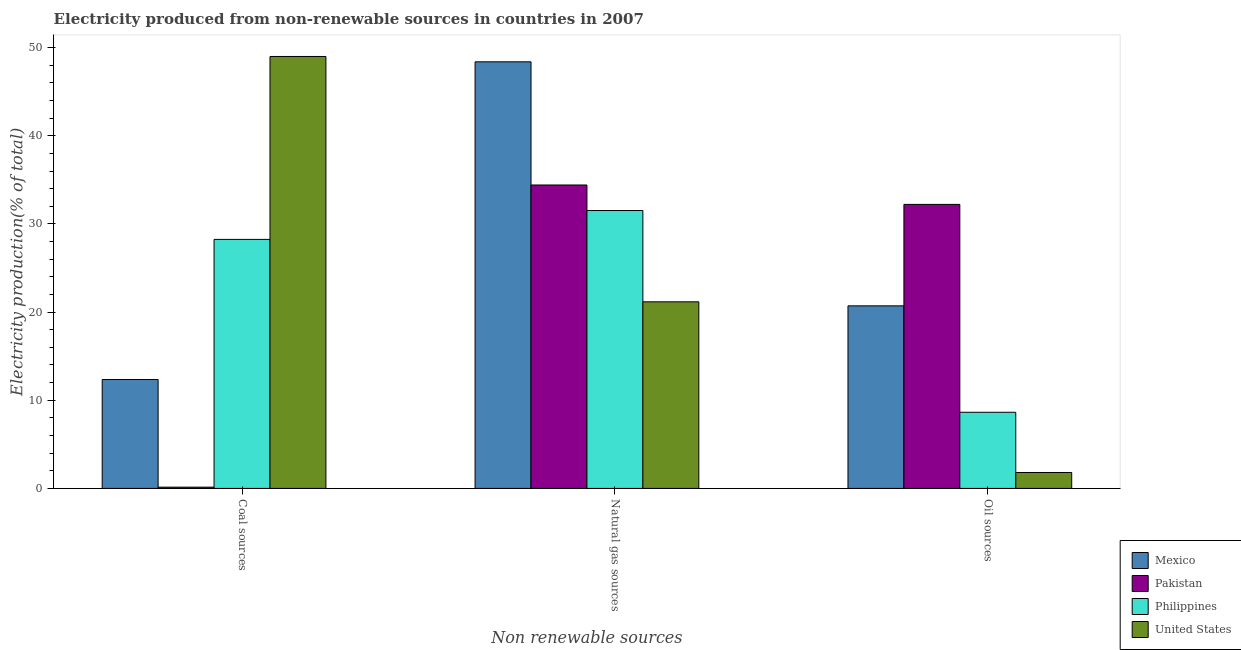Are the number of bars per tick equal to the number of legend labels?
Give a very brief answer. Yes. How many bars are there on the 3rd tick from the left?
Offer a very short reply. 4. How many bars are there on the 3rd tick from the right?
Your response must be concise. 4. What is the label of the 1st group of bars from the left?
Give a very brief answer. Coal sources. What is the percentage of electricity produced by natural gas in United States?
Your answer should be compact. 21.17. Across all countries, what is the maximum percentage of electricity produced by natural gas?
Make the answer very short. 48.39. Across all countries, what is the minimum percentage of electricity produced by coal?
Provide a succinct answer. 0.14. What is the total percentage of electricity produced by oil sources in the graph?
Your answer should be compact. 63.37. What is the difference between the percentage of electricity produced by oil sources in Philippines and that in United States?
Give a very brief answer. 6.83. What is the difference between the percentage of electricity produced by natural gas in Mexico and the percentage of electricity produced by coal in Pakistan?
Your answer should be very brief. 48.24. What is the average percentage of electricity produced by oil sources per country?
Offer a terse response. 15.84. What is the difference between the percentage of electricity produced by oil sources and percentage of electricity produced by natural gas in Pakistan?
Ensure brevity in your answer.  -2.2. In how many countries, is the percentage of electricity produced by coal greater than 44 %?
Your answer should be compact. 1. What is the ratio of the percentage of electricity produced by coal in Mexico to that in Philippines?
Keep it short and to the point. 0.44. What is the difference between the highest and the second highest percentage of electricity produced by oil sources?
Your response must be concise. 11.51. What is the difference between the highest and the lowest percentage of electricity produced by oil sources?
Keep it short and to the point. 30.41. Is it the case that in every country, the sum of the percentage of electricity produced by coal and percentage of electricity produced by natural gas is greater than the percentage of electricity produced by oil sources?
Ensure brevity in your answer.  Yes. Are the values on the major ticks of Y-axis written in scientific E-notation?
Provide a succinct answer. No. Does the graph contain grids?
Offer a terse response. No. Where does the legend appear in the graph?
Ensure brevity in your answer.  Bottom right. How many legend labels are there?
Your response must be concise. 4. How are the legend labels stacked?
Provide a short and direct response. Vertical. What is the title of the graph?
Make the answer very short. Electricity produced from non-renewable sources in countries in 2007. Does "Germany" appear as one of the legend labels in the graph?
Your answer should be compact. No. What is the label or title of the X-axis?
Ensure brevity in your answer.  Non renewable sources. What is the label or title of the Y-axis?
Your answer should be very brief. Electricity production(% of total). What is the Electricity production(% of total) in Mexico in Coal sources?
Your response must be concise. 12.35. What is the Electricity production(% of total) in Pakistan in Coal sources?
Offer a terse response. 0.14. What is the Electricity production(% of total) in Philippines in Coal sources?
Provide a succinct answer. 28.24. What is the Electricity production(% of total) in United States in Coal sources?
Offer a terse response. 48.99. What is the Electricity production(% of total) in Mexico in Natural gas sources?
Ensure brevity in your answer.  48.39. What is the Electricity production(% of total) of Pakistan in Natural gas sources?
Make the answer very short. 34.42. What is the Electricity production(% of total) in Philippines in Natural gas sources?
Offer a very short reply. 31.52. What is the Electricity production(% of total) of United States in Natural gas sources?
Make the answer very short. 21.17. What is the Electricity production(% of total) in Mexico in Oil sources?
Offer a very short reply. 20.71. What is the Electricity production(% of total) of Pakistan in Oil sources?
Ensure brevity in your answer.  32.22. What is the Electricity production(% of total) of Philippines in Oil sources?
Your answer should be compact. 8.64. What is the Electricity production(% of total) of United States in Oil sources?
Give a very brief answer. 1.81. Across all Non renewable sources, what is the maximum Electricity production(% of total) in Mexico?
Offer a very short reply. 48.39. Across all Non renewable sources, what is the maximum Electricity production(% of total) of Pakistan?
Provide a succinct answer. 34.42. Across all Non renewable sources, what is the maximum Electricity production(% of total) in Philippines?
Give a very brief answer. 31.52. Across all Non renewable sources, what is the maximum Electricity production(% of total) in United States?
Offer a terse response. 48.99. Across all Non renewable sources, what is the minimum Electricity production(% of total) in Mexico?
Provide a short and direct response. 12.35. Across all Non renewable sources, what is the minimum Electricity production(% of total) in Pakistan?
Provide a short and direct response. 0.14. Across all Non renewable sources, what is the minimum Electricity production(% of total) in Philippines?
Provide a short and direct response. 8.64. Across all Non renewable sources, what is the minimum Electricity production(% of total) in United States?
Your answer should be very brief. 1.81. What is the total Electricity production(% of total) in Mexico in the graph?
Your answer should be very brief. 81.45. What is the total Electricity production(% of total) of Pakistan in the graph?
Keep it short and to the point. 66.77. What is the total Electricity production(% of total) of Philippines in the graph?
Your answer should be compact. 68.4. What is the total Electricity production(% of total) in United States in the graph?
Ensure brevity in your answer.  71.97. What is the difference between the Electricity production(% of total) in Mexico in Coal sources and that in Natural gas sources?
Offer a terse response. -36.03. What is the difference between the Electricity production(% of total) of Pakistan in Coal sources and that in Natural gas sources?
Make the answer very short. -34.27. What is the difference between the Electricity production(% of total) of Philippines in Coal sources and that in Natural gas sources?
Make the answer very short. -3.27. What is the difference between the Electricity production(% of total) of United States in Coal sources and that in Natural gas sources?
Provide a short and direct response. 27.83. What is the difference between the Electricity production(% of total) of Mexico in Coal sources and that in Oil sources?
Offer a very short reply. -8.35. What is the difference between the Electricity production(% of total) in Pakistan in Coal sources and that in Oil sources?
Offer a terse response. -32.07. What is the difference between the Electricity production(% of total) in Philippines in Coal sources and that in Oil sources?
Your response must be concise. 19.61. What is the difference between the Electricity production(% of total) of United States in Coal sources and that in Oil sources?
Your answer should be compact. 47.19. What is the difference between the Electricity production(% of total) in Mexico in Natural gas sources and that in Oil sources?
Provide a succinct answer. 27.68. What is the difference between the Electricity production(% of total) in Pakistan in Natural gas sources and that in Oil sources?
Give a very brief answer. 2.2. What is the difference between the Electricity production(% of total) in Philippines in Natural gas sources and that in Oil sources?
Ensure brevity in your answer.  22.88. What is the difference between the Electricity production(% of total) of United States in Natural gas sources and that in Oil sources?
Your answer should be compact. 19.36. What is the difference between the Electricity production(% of total) in Mexico in Coal sources and the Electricity production(% of total) in Pakistan in Natural gas sources?
Ensure brevity in your answer.  -22.06. What is the difference between the Electricity production(% of total) in Mexico in Coal sources and the Electricity production(% of total) in Philippines in Natural gas sources?
Make the answer very short. -19.17. What is the difference between the Electricity production(% of total) of Mexico in Coal sources and the Electricity production(% of total) of United States in Natural gas sources?
Offer a terse response. -8.81. What is the difference between the Electricity production(% of total) of Pakistan in Coal sources and the Electricity production(% of total) of Philippines in Natural gas sources?
Provide a succinct answer. -31.38. What is the difference between the Electricity production(% of total) in Pakistan in Coal sources and the Electricity production(% of total) in United States in Natural gas sources?
Provide a short and direct response. -21.02. What is the difference between the Electricity production(% of total) in Philippines in Coal sources and the Electricity production(% of total) in United States in Natural gas sources?
Your answer should be compact. 7.08. What is the difference between the Electricity production(% of total) of Mexico in Coal sources and the Electricity production(% of total) of Pakistan in Oil sources?
Provide a short and direct response. -19.86. What is the difference between the Electricity production(% of total) in Mexico in Coal sources and the Electricity production(% of total) in Philippines in Oil sources?
Ensure brevity in your answer.  3.72. What is the difference between the Electricity production(% of total) of Mexico in Coal sources and the Electricity production(% of total) of United States in Oil sources?
Your answer should be compact. 10.55. What is the difference between the Electricity production(% of total) in Pakistan in Coal sources and the Electricity production(% of total) in Philippines in Oil sources?
Provide a short and direct response. -8.49. What is the difference between the Electricity production(% of total) in Pakistan in Coal sources and the Electricity production(% of total) in United States in Oil sources?
Ensure brevity in your answer.  -1.66. What is the difference between the Electricity production(% of total) of Philippines in Coal sources and the Electricity production(% of total) of United States in Oil sources?
Keep it short and to the point. 26.44. What is the difference between the Electricity production(% of total) in Mexico in Natural gas sources and the Electricity production(% of total) in Pakistan in Oil sources?
Keep it short and to the point. 16.17. What is the difference between the Electricity production(% of total) of Mexico in Natural gas sources and the Electricity production(% of total) of Philippines in Oil sources?
Keep it short and to the point. 39.75. What is the difference between the Electricity production(% of total) of Mexico in Natural gas sources and the Electricity production(% of total) of United States in Oil sources?
Provide a succinct answer. 46.58. What is the difference between the Electricity production(% of total) of Pakistan in Natural gas sources and the Electricity production(% of total) of Philippines in Oil sources?
Make the answer very short. 25.78. What is the difference between the Electricity production(% of total) in Pakistan in Natural gas sources and the Electricity production(% of total) in United States in Oil sources?
Keep it short and to the point. 32.61. What is the difference between the Electricity production(% of total) of Philippines in Natural gas sources and the Electricity production(% of total) of United States in Oil sources?
Provide a succinct answer. 29.71. What is the average Electricity production(% of total) of Mexico per Non renewable sources?
Make the answer very short. 27.15. What is the average Electricity production(% of total) in Pakistan per Non renewable sources?
Offer a terse response. 22.26. What is the average Electricity production(% of total) of Philippines per Non renewable sources?
Offer a terse response. 22.8. What is the average Electricity production(% of total) in United States per Non renewable sources?
Provide a succinct answer. 23.99. What is the difference between the Electricity production(% of total) of Mexico and Electricity production(% of total) of Pakistan in Coal sources?
Provide a succinct answer. 12.21. What is the difference between the Electricity production(% of total) in Mexico and Electricity production(% of total) in Philippines in Coal sources?
Offer a terse response. -15.89. What is the difference between the Electricity production(% of total) in Mexico and Electricity production(% of total) in United States in Coal sources?
Offer a terse response. -36.64. What is the difference between the Electricity production(% of total) in Pakistan and Electricity production(% of total) in Philippines in Coal sources?
Your response must be concise. -28.1. What is the difference between the Electricity production(% of total) in Pakistan and Electricity production(% of total) in United States in Coal sources?
Your answer should be compact. -48.85. What is the difference between the Electricity production(% of total) of Philippines and Electricity production(% of total) of United States in Coal sources?
Give a very brief answer. -20.75. What is the difference between the Electricity production(% of total) of Mexico and Electricity production(% of total) of Pakistan in Natural gas sources?
Give a very brief answer. 13.97. What is the difference between the Electricity production(% of total) in Mexico and Electricity production(% of total) in Philippines in Natural gas sources?
Your response must be concise. 16.87. What is the difference between the Electricity production(% of total) in Mexico and Electricity production(% of total) in United States in Natural gas sources?
Your answer should be compact. 27.22. What is the difference between the Electricity production(% of total) of Pakistan and Electricity production(% of total) of Philippines in Natural gas sources?
Offer a very short reply. 2.9. What is the difference between the Electricity production(% of total) of Pakistan and Electricity production(% of total) of United States in Natural gas sources?
Provide a succinct answer. 13.25. What is the difference between the Electricity production(% of total) in Philippines and Electricity production(% of total) in United States in Natural gas sources?
Provide a short and direct response. 10.35. What is the difference between the Electricity production(% of total) in Mexico and Electricity production(% of total) in Pakistan in Oil sources?
Provide a succinct answer. -11.51. What is the difference between the Electricity production(% of total) of Mexico and Electricity production(% of total) of Philippines in Oil sources?
Your answer should be very brief. 12.07. What is the difference between the Electricity production(% of total) of Mexico and Electricity production(% of total) of United States in Oil sources?
Keep it short and to the point. 18.9. What is the difference between the Electricity production(% of total) in Pakistan and Electricity production(% of total) in Philippines in Oil sources?
Make the answer very short. 23.58. What is the difference between the Electricity production(% of total) in Pakistan and Electricity production(% of total) in United States in Oil sources?
Offer a very short reply. 30.41. What is the difference between the Electricity production(% of total) in Philippines and Electricity production(% of total) in United States in Oil sources?
Give a very brief answer. 6.83. What is the ratio of the Electricity production(% of total) in Mexico in Coal sources to that in Natural gas sources?
Your response must be concise. 0.26. What is the ratio of the Electricity production(% of total) of Pakistan in Coal sources to that in Natural gas sources?
Provide a short and direct response. 0. What is the ratio of the Electricity production(% of total) in Philippines in Coal sources to that in Natural gas sources?
Offer a terse response. 0.9. What is the ratio of the Electricity production(% of total) in United States in Coal sources to that in Natural gas sources?
Provide a short and direct response. 2.31. What is the ratio of the Electricity production(% of total) in Mexico in Coal sources to that in Oil sources?
Your response must be concise. 0.6. What is the ratio of the Electricity production(% of total) in Pakistan in Coal sources to that in Oil sources?
Your answer should be compact. 0. What is the ratio of the Electricity production(% of total) of Philippines in Coal sources to that in Oil sources?
Provide a short and direct response. 3.27. What is the ratio of the Electricity production(% of total) in United States in Coal sources to that in Oil sources?
Your answer should be compact. 27.11. What is the ratio of the Electricity production(% of total) in Mexico in Natural gas sources to that in Oil sources?
Your answer should be compact. 2.34. What is the ratio of the Electricity production(% of total) of Pakistan in Natural gas sources to that in Oil sources?
Your response must be concise. 1.07. What is the ratio of the Electricity production(% of total) in Philippines in Natural gas sources to that in Oil sources?
Offer a terse response. 3.65. What is the ratio of the Electricity production(% of total) in United States in Natural gas sources to that in Oil sources?
Your response must be concise. 11.71. What is the difference between the highest and the second highest Electricity production(% of total) of Mexico?
Offer a terse response. 27.68. What is the difference between the highest and the second highest Electricity production(% of total) of Pakistan?
Offer a terse response. 2.2. What is the difference between the highest and the second highest Electricity production(% of total) in Philippines?
Make the answer very short. 3.27. What is the difference between the highest and the second highest Electricity production(% of total) in United States?
Your response must be concise. 27.83. What is the difference between the highest and the lowest Electricity production(% of total) of Mexico?
Give a very brief answer. 36.03. What is the difference between the highest and the lowest Electricity production(% of total) of Pakistan?
Your answer should be compact. 34.27. What is the difference between the highest and the lowest Electricity production(% of total) of Philippines?
Your answer should be very brief. 22.88. What is the difference between the highest and the lowest Electricity production(% of total) in United States?
Provide a succinct answer. 47.19. 